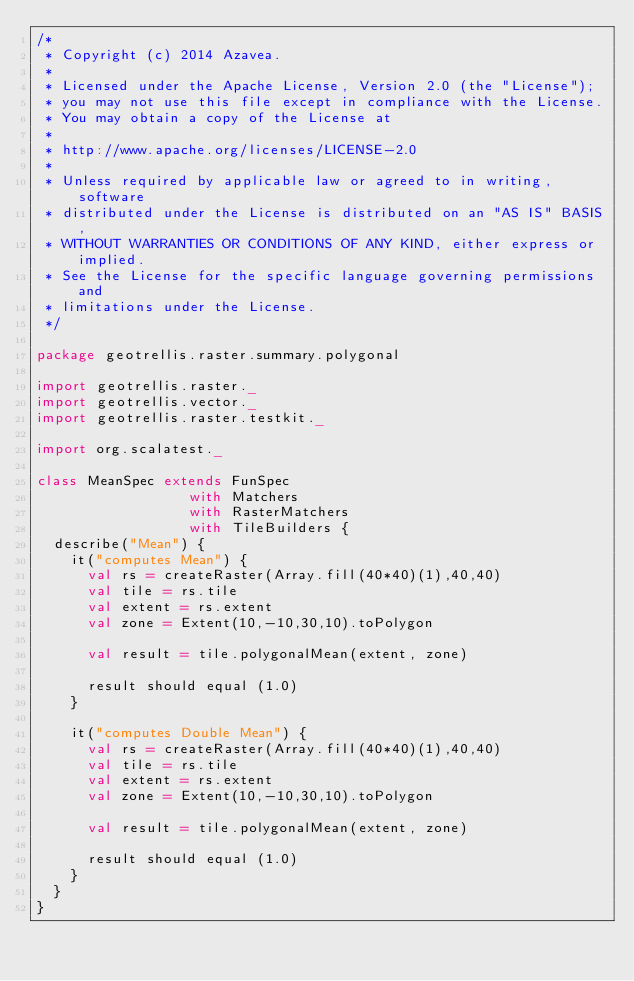Convert code to text. <code><loc_0><loc_0><loc_500><loc_500><_Scala_>/*
 * Copyright (c) 2014 Azavea.
 * 
 * Licensed under the Apache License, Version 2.0 (the "License");
 * you may not use this file except in compliance with the License.
 * You may obtain a copy of the License at
 * 
 * http://www.apache.org/licenses/LICENSE-2.0
 * 
 * Unless required by applicable law or agreed to in writing, software
 * distributed under the License is distributed on an "AS IS" BASIS,
 * WITHOUT WARRANTIES OR CONDITIONS OF ANY KIND, either express or implied.
 * See the License for the specific language governing permissions and
 * limitations under the License.
 */

package geotrellis.raster.summary.polygonal

import geotrellis.raster._
import geotrellis.vector._
import geotrellis.raster.testkit._

import org.scalatest._

class MeanSpec extends FunSpec
                  with Matchers
                  with RasterMatchers
                  with TileBuilders {
  describe("Mean") {
    it("computes Mean") {
      val rs = createRaster(Array.fill(40*40)(1),40,40)
      val tile = rs.tile
      val extent = rs.extent
      val zone = Extent(10,-10,30,10).toPolygon

      val result = tile.polygonalMean(extent, zone)
      
      result should equal (1.0)
    }

    it("computes Double Mean") {
      val rs = createRaster(Array.fill(40*40)(1),40,40)
      val tile = rs.tile
      val extent = rs.extent
      val zone = Extent(10,-10,30,10).toPolygon

      val result = tile.polygonalMean(extent, zone)

      result should equal (1.0)
    }
  }
}
</code> 